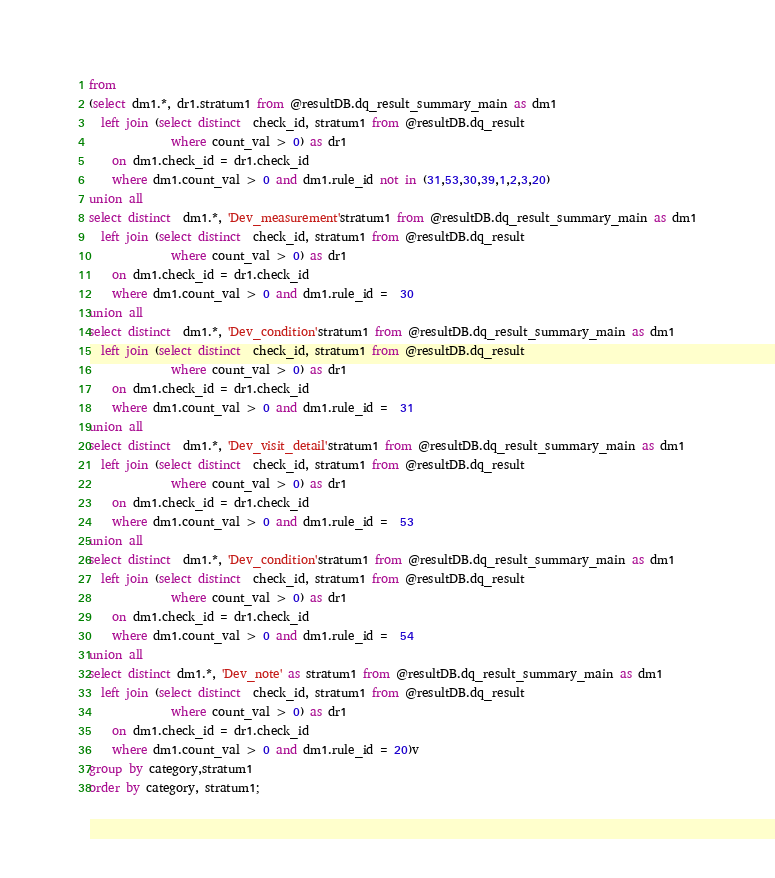<code> <loc_0><loc_0><loc_500><loc_500><_SQL_>
from
(select dm1.*, dr1.stratum1 from @resultDB.dq_result_summary_main as dm1
  left join (select distinct  check_id, stratum1 from @resultDB.dq_result
              where count_val > 0) as dr1
    on dm1.check_id = dr1.check_id
    where dm1.count_val > 0 and dm1.rule_id not in (31,53,30,39,1,2,3,20)
union all
select distinct  dm1.*, 'Dev_measurement'stratum1 from @resultDB.dq_result_summary_main as dm1
  left join (select distinct  check_id, stratum1 from @resultDB.dq_result
              where count_val > 0) as dr1
    on dm1.check_id = dr1.check_id
    where dm1.count_val > 0 and dm1.rule_id =  30
union all
select distinct  dm1.*, 'Dev_condition'stratum1 from @resultDB.dq_result_summary_main as dm1
  left join (select distinct  check_id, stratum1 from @resultDB.dq_result
              where count_val > 0) as dr1
    on dm1.check_id = dr1.check_id
    where dm1.count_val > 0 and dm1.rule_id =  31
union all
select distinct  dm1.*, 'Dev_visit_detail'stratum1 from @resultDB.dq_result_summary_main as dm1
  left join (select distinct  check_id, stratum1 from @resultDB.dq_result
              where count_val > 0) as dr1
    on dm1.check_id = dr1.check_id
    where dm1.count_val > 0 and dm1.rule_id =  53
union all
select distinct  dm1.*, 'Dev_condition'stratum1 from @resultDB.dq_result_summary_main as dm1
  left join (select distinct  check_id, stratum1 from @resultDB.dq_result
              where count_val > 0) as dr1
    on dm1.check_id = dr1.check_id
    where dm1.count_val > 0 and dm1.rule_id =  54
union all
select distinct dm1.*, 'Dev_note' as stratum1 from @resultDB.dq_result_summary_main as dm1
  left join (select distinct  check_id, stratum1 from @resultDB.dq_result
              where count_val > 0) as dr1
    on dm1.check_id = dr1.check_id
    where dm1.count_val > 0 and dm1.rule_id = 20)v
group by category,stratum1
order by category, stratum1;</code> 